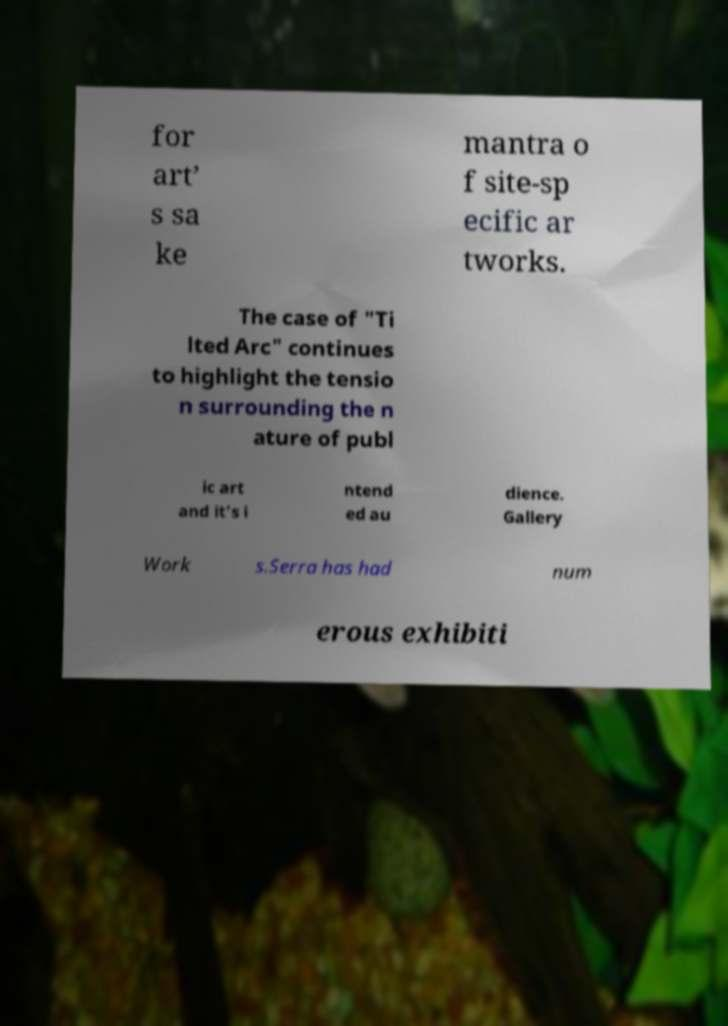For documentation purposes, I need the text within this image transcribed. Could you provide that? for art’ s sa ke mantra o f site-sp ecific ar tworks. The case of "Ti lted Arc" continues to highlight the tensio n surrounding the n ature of publ ic art and it’s i ntend ed au dience. Gallery Work s.Serra has had num erous exhibiti 